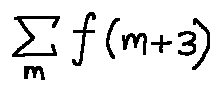Convert formula to latex. <formula><loc_0><loc_0><loc_500><loc_500>\sum \lim i t s _ { m } f ( m + 3 )</formula> 